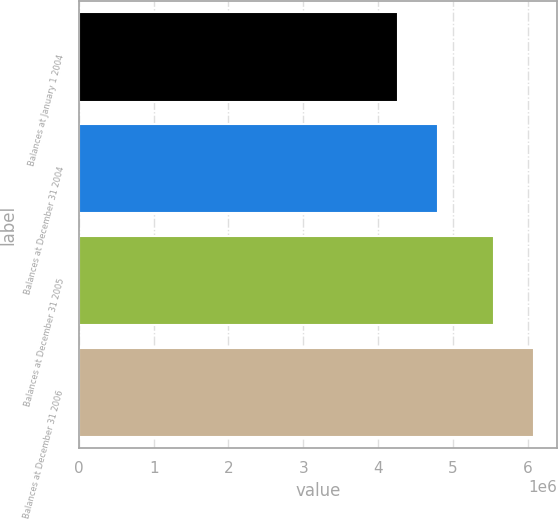Convert chart. <chart><loc_0><loc_0><loc_500><loc_500><bar_chart><fcel>Balances at January 1 2004<fcel>Balances at December 31 2004<fcel>Balances at December 31 2005<fcel>Balances at December 31 2006<nl><fcel>4.2629e+06<fcel>4.80452e+06<fcel>5.55446e+06<fcel>6.09158e+06<nl></chart> 